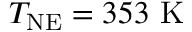Convert formula to latex. <formula><loc_0><loc_0><loc_500><loc_500>T _ { N E } = 3 5 3 \ K</formula> 